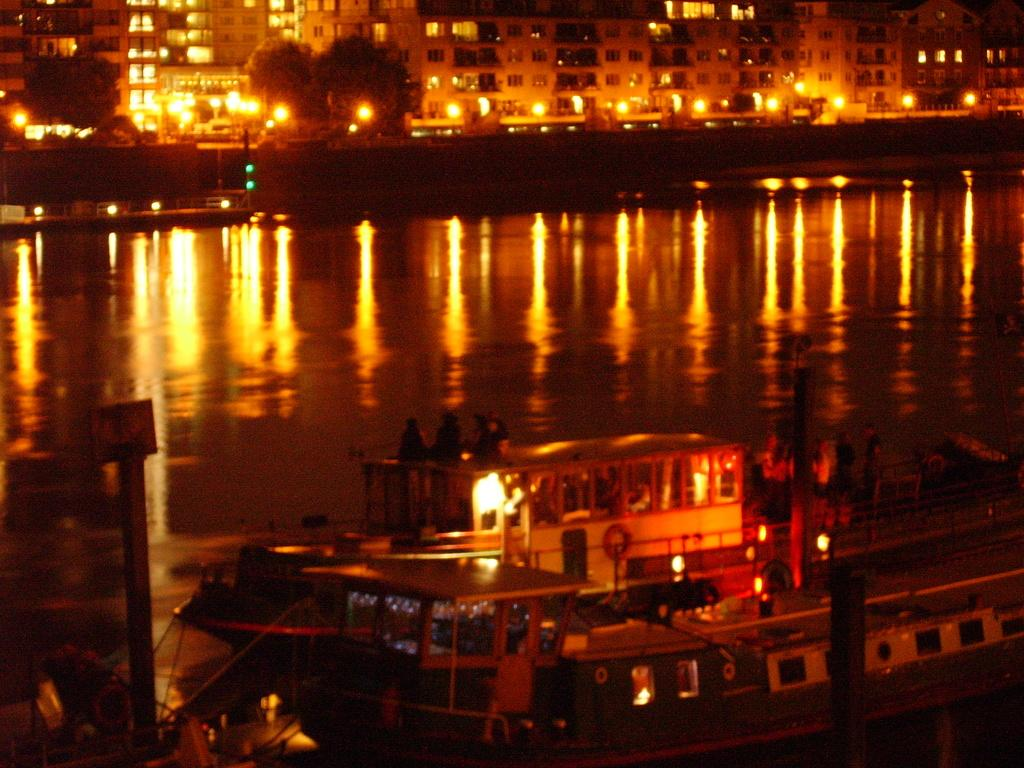What is the lighting condition in the image? The image was taken in the dark. What is the main subject at the bottom of the image? There is a ship at the bottom of the image. Where is the ship located? The ship is on the water. What can be seen in the background of the image? There are buildings, trees, and lights in the background of the image. Can you see any bubbles coming from the pig in the image? There is no pig or bubbles present in the image. How hot is the water in the image? The temperature of the water is not mentioned in the image, and therefore it cannot be determined. 